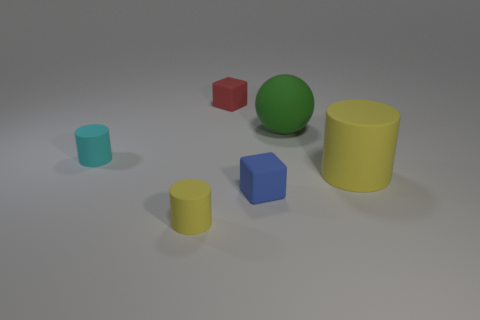Is the big sphere the same color as the big cylinder?
Provide a succinct answer. No. There is a small matte cylinder that is right of the small cyan object; does it have the same color as the big matte cylinder?
Make the answer very short. Yes. There is a object that is the same color as the large cylinder; what is its shape?
Provide a short and direct response. Cylinder. Are there any tiny matte cylinders of the same color as the big rubber cylinder?
Offer a very short reply. Yes. How many yellow cylinders are there?
Keep it short and to the point. 2. Do the small matte cylinder in front of the big matte cylinder and the matte cylinder to the right of the tiny yellow cylinder have the same color?
Provide a succinct answer. Yes. How many other objects are the same size as the green matte sphere?
Your response must be concise. 1. There is a tiny thing to the right of the red matte block; what is its color?
Your response must be concise. Blue. Are the block that is behind the big yellow rubber object and the large green ball made of the same material?
Your answer should be very brief. Yes. How many rubber cylinders are both on the right side of the small yellow object and on the left side of the large yellow matte cylinder?
Give a very brief answer. 0. 